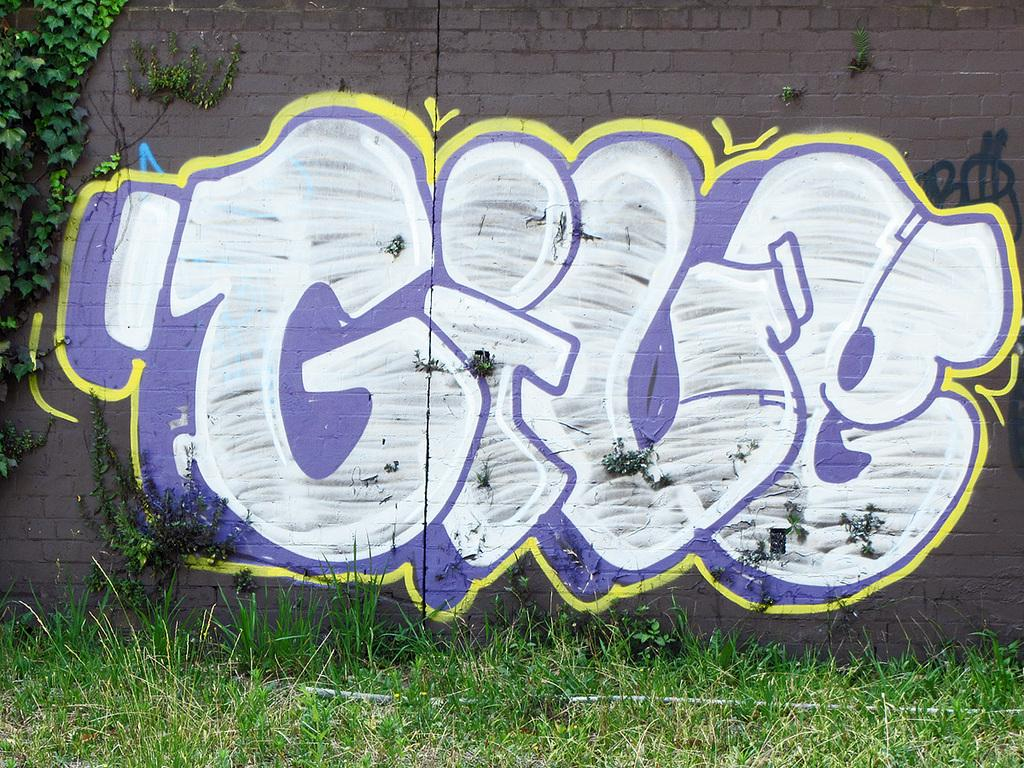What type of vegetation is present in the image? There is grass in the image. What can be found on the wall in the image? There is a painting on the wall in the image. What other type of vegetation is present in the image besides grass? There are plants in the image. Can you tell me how many horses are depicted in the painting on the wall? There is no information about a painting of horses in the image; the painting's content is not mentioned in the provided facts. 